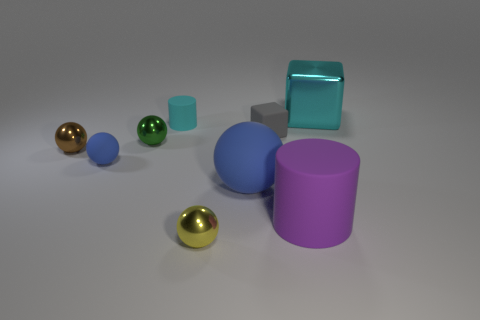What is the shape of the shiny object that is the same color as the small rubber cylinder?
Keep it short and to the point. Cube. Is there any other thing that has the same color as the big matte cylinder?
Ensure brevity in your answer.  No. Do the small matte object that is right of the cyan rubber object and the block right of the small gray rubber cube have the same color?
Ensure brevity in your answer.  No. Are there more small things to the right of the big cyan metallic thing than yellow objects left of the brown shiny thing?
Your response must be concise. No. What material is the brown sphere?
Offer a very short reply. Metal. There is a cyan thing on the left side of the large object that is behind the cyan object that is in front of the cyan metallic thing; what shape is it?
Your answer should be compact. Cylinder. What number of other things are the same material as the small cylinder?
Your response must be concise. 4. Does the big object behind the tiny blue sphere have the same material as the cyan object that is to the left of the large cyan metal block?
Provide a succinct answer. No. What number of things are both on the right side of the tiny gray block and in front of the small brown shiny object?
Your answer should be very brief. 1. Are there any big cyan metal things of the same shape as the tiny cyan thing?
Make the answer very short. No. 